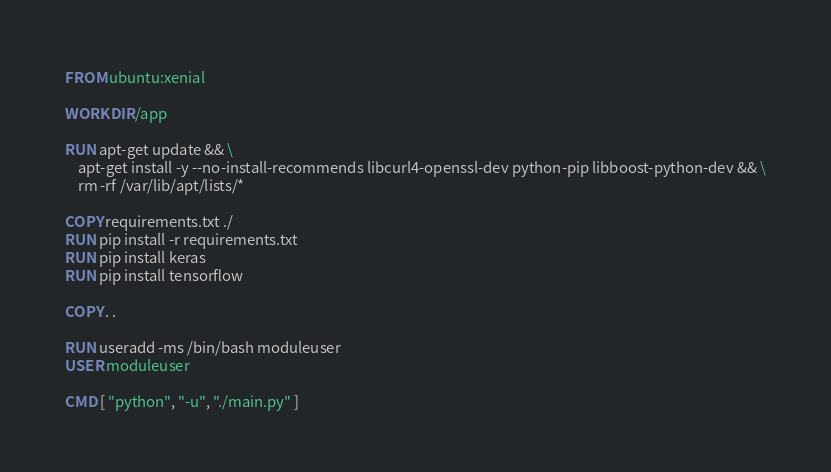<code> <loc_0><loc_0><loc_500><loc_500><_Dockerfile_>FROM ubuntu:xenial

WORKDIR /app

RUN apt-get update && \
    apt-get install -y --no-install-recommends libcurl4-openssl-dev python-pip libboost-python-dev && \
    rm -rf /var/lib/apt/lists/* 

COPY requirements.txt ./
RUN pip install -r requirements.txt
RUN pip install keras
RUN pip install tensorflow

COPY . .

RUN useradd -ms /bin/bash moduleuser
USER moduleuser

CMD [ "python", "-u", "./main.py" ]</code> 